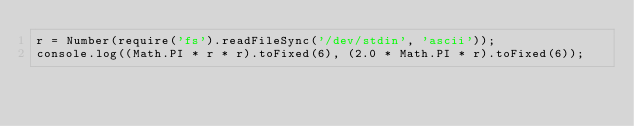Convert code to text. <code><loc_0><loc_0><loc_500><loc_500><_JavaScript_>r = Number(require('fs').readFileSync('/dev/stdin', 'ascii'));
console.log((Math.PI * r * r).toFixed(6), (2.0 * Math.PI * r).toFixed(6));</code> 